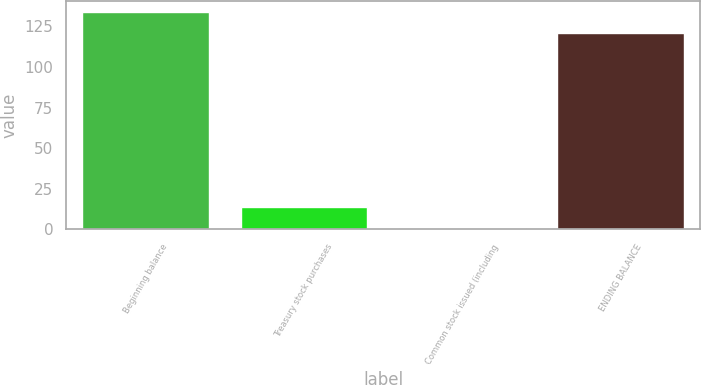Convert chart to OTSL. <chart><loc_0><loc_0><loc_500><loc_500><bar_chart><fcel>Beginning balance<fcel>Treasury stock purchases<fcel>Common stock issued (including<fcel>ENDING BALANCE<nl><fcel>133.75<fcel>13.65<fcel>0.9<fcel>121<nl></chart> 